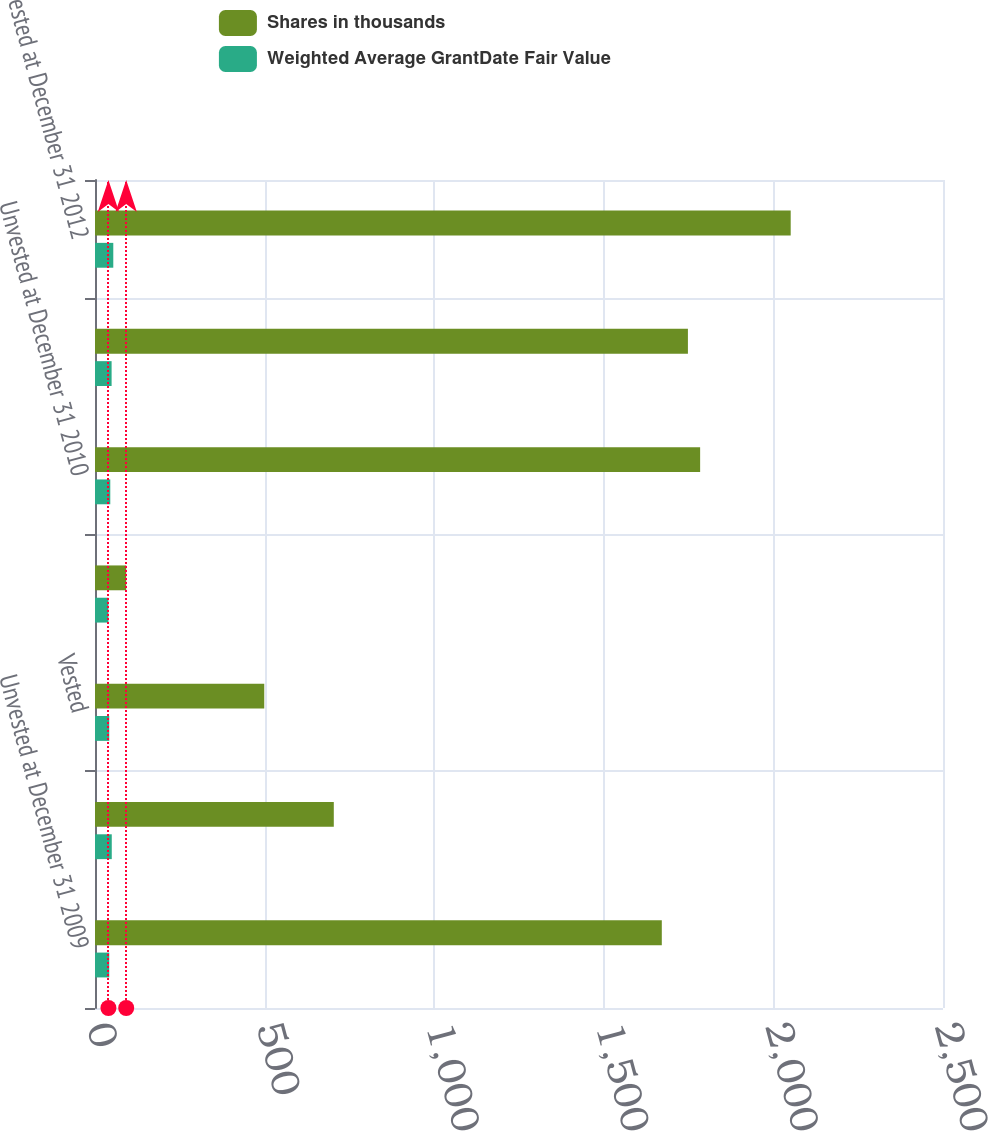Convert chart. <chart><loc_0><loc_0><loc_500><loc_500><stacked_bar_chart><ecel><fcel>Unvested at December 31 2009<fcel>Granted<fcel>Vested<fcel>Forfeited<fcel>Unvested at December 31 2010<fcel>Unvested at December 31 2011<fcel>Unvested at December 31 2012<nl><fcel>Shares in thousands<fcel>1671<fcel>704<fcel>499<fcel>92<fcel>1784<fcel>1748<fcel>2051<nl><fcel>Weighted Average GrantDate Fair Value<fcel>41.99<fcel>49.43<fcel>42<fcel>39.56<fcel>45.05<fcel>48.96<fcel>53.91<nl></chart> 